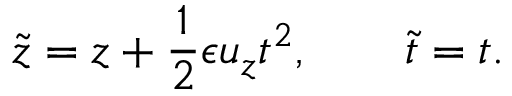<formula> <loc_0><loc_0><loc_500><loc_500>{ \tilde { z } } = z + \frac { 1 } { 2 } \epsilon u _ { z } t ^ { 2 } , \quad { \tilde { t } } = t .</formula> 